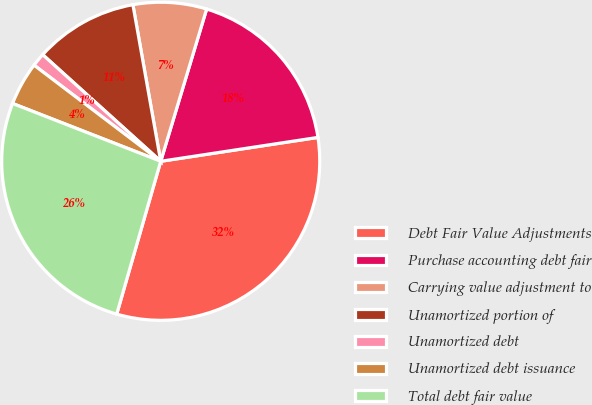Convert chart to OTSL. <chart><loc_0><loc_0><loc_500><loc_500><pie_chart><fcel>Debt Fair Value Adjustments<fcel>Purchase accounting debt fair<fcel>Carrying value adjustment to<fcel>Unamortized portion of<fcel>Unamortized debt<fcel>Unamortized debt issuance<fcel>Total debt fair value<nl><fcel>31.86%<fcel>17.94%<fcel>7.46%<fcel>10.51%<fcel>1.36%<fcel>4.41%<fcel>26.46%<nl></chart> 